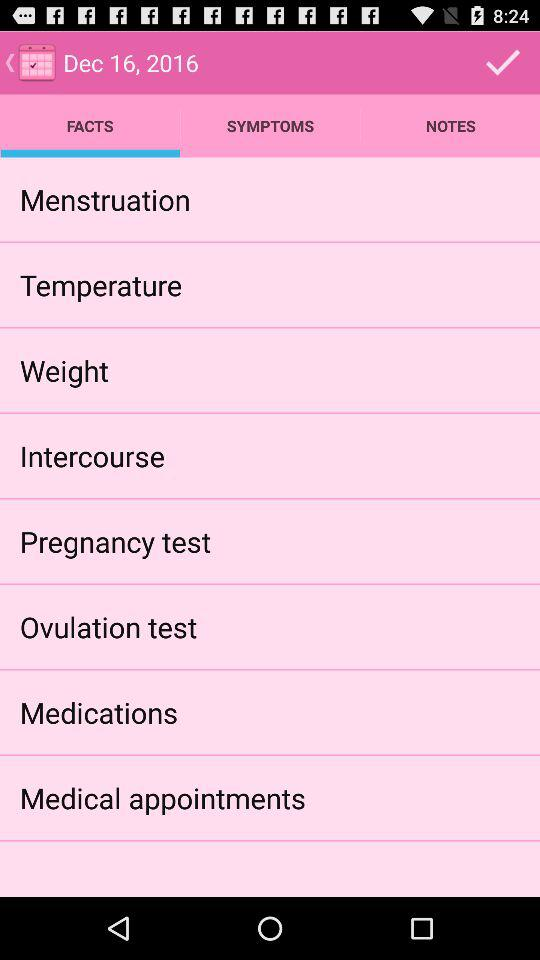What is the selected date? The selected date is December 16, 2016. 